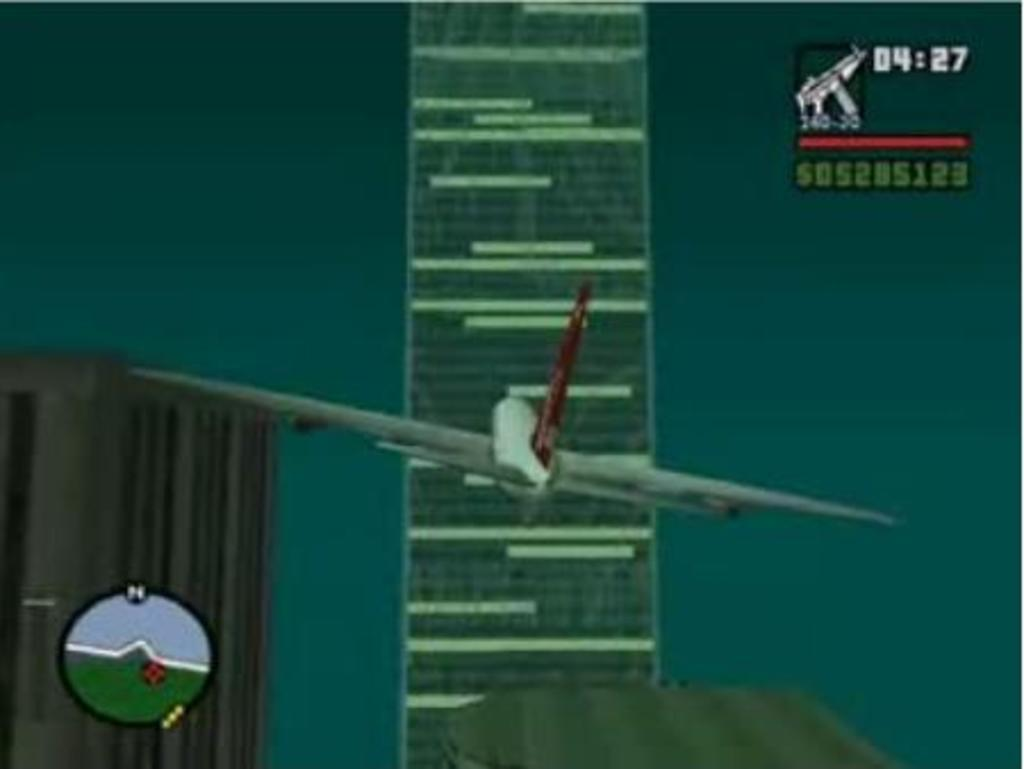<image>
Offer a succinct explanation of the picture presented. A plane in a video game is flying toward a building with a timer showing 04:27. 